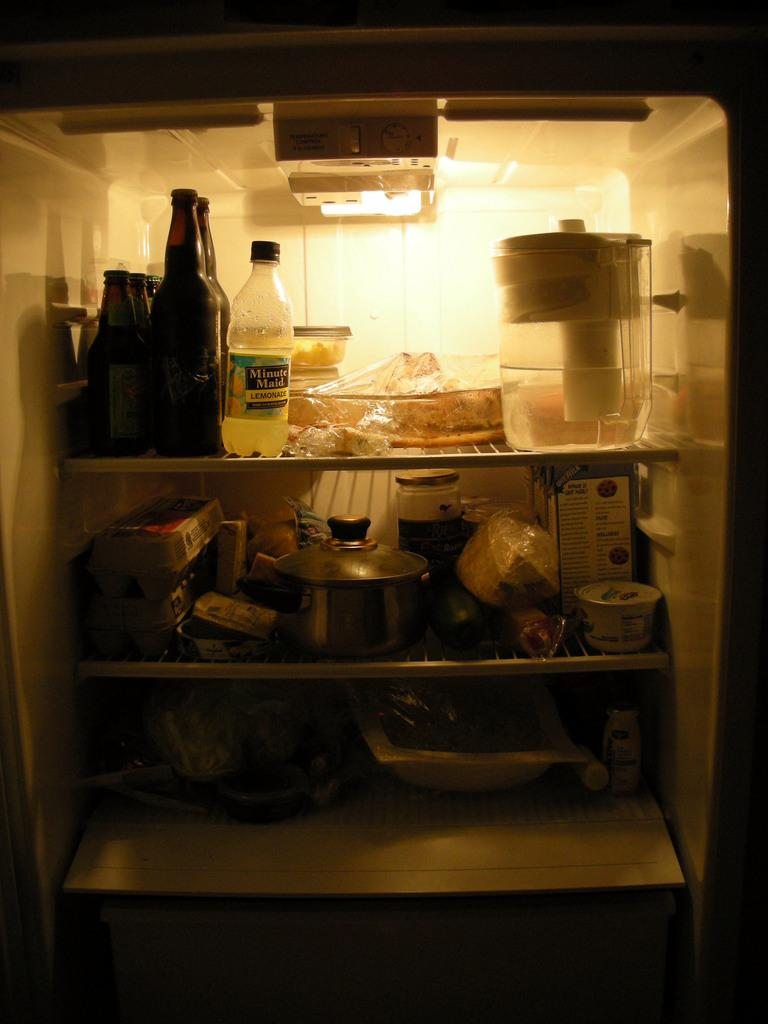<image>
Relay a brief, clear account of the picture shown. The inside of a refrigerator with a bottle of minute maid lemonade among other things inside. 